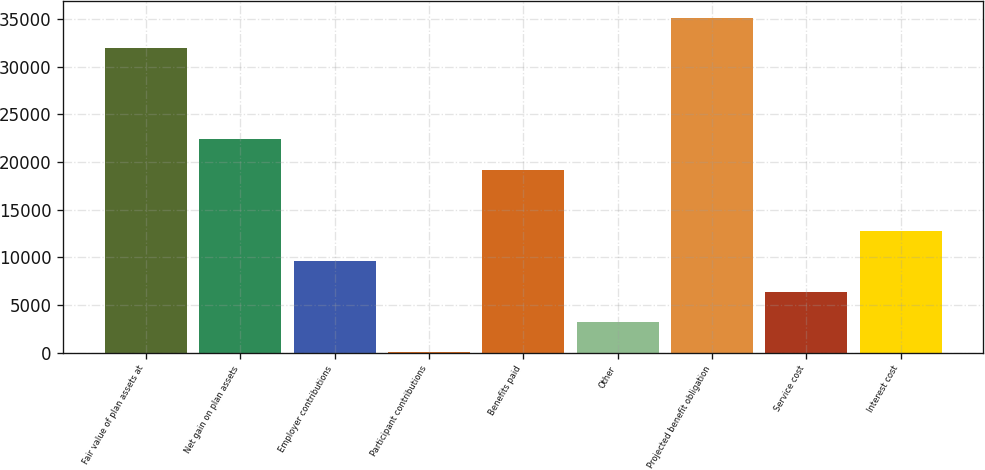<chart> <loc_0><loc_0><loc_500><loc_500><bar_chart><fcel>Fair value of plan assets at<fcel>Net gain on plan assets<fcel>Employer contributions<fcel>Participant contributions<fcel>Benefits paid<fcel>Other<fcel>Projected benefit obligation<fcel>Service cost<fcel>Interest cost<nl><fcel>31967<fcel>22380.2<fcel>9597.8<fcel>11<fcel>19184.6<fcel>3206.6<fcel>35162.6<fcel>6402.2<fcel>12793.4<nl></chart> 